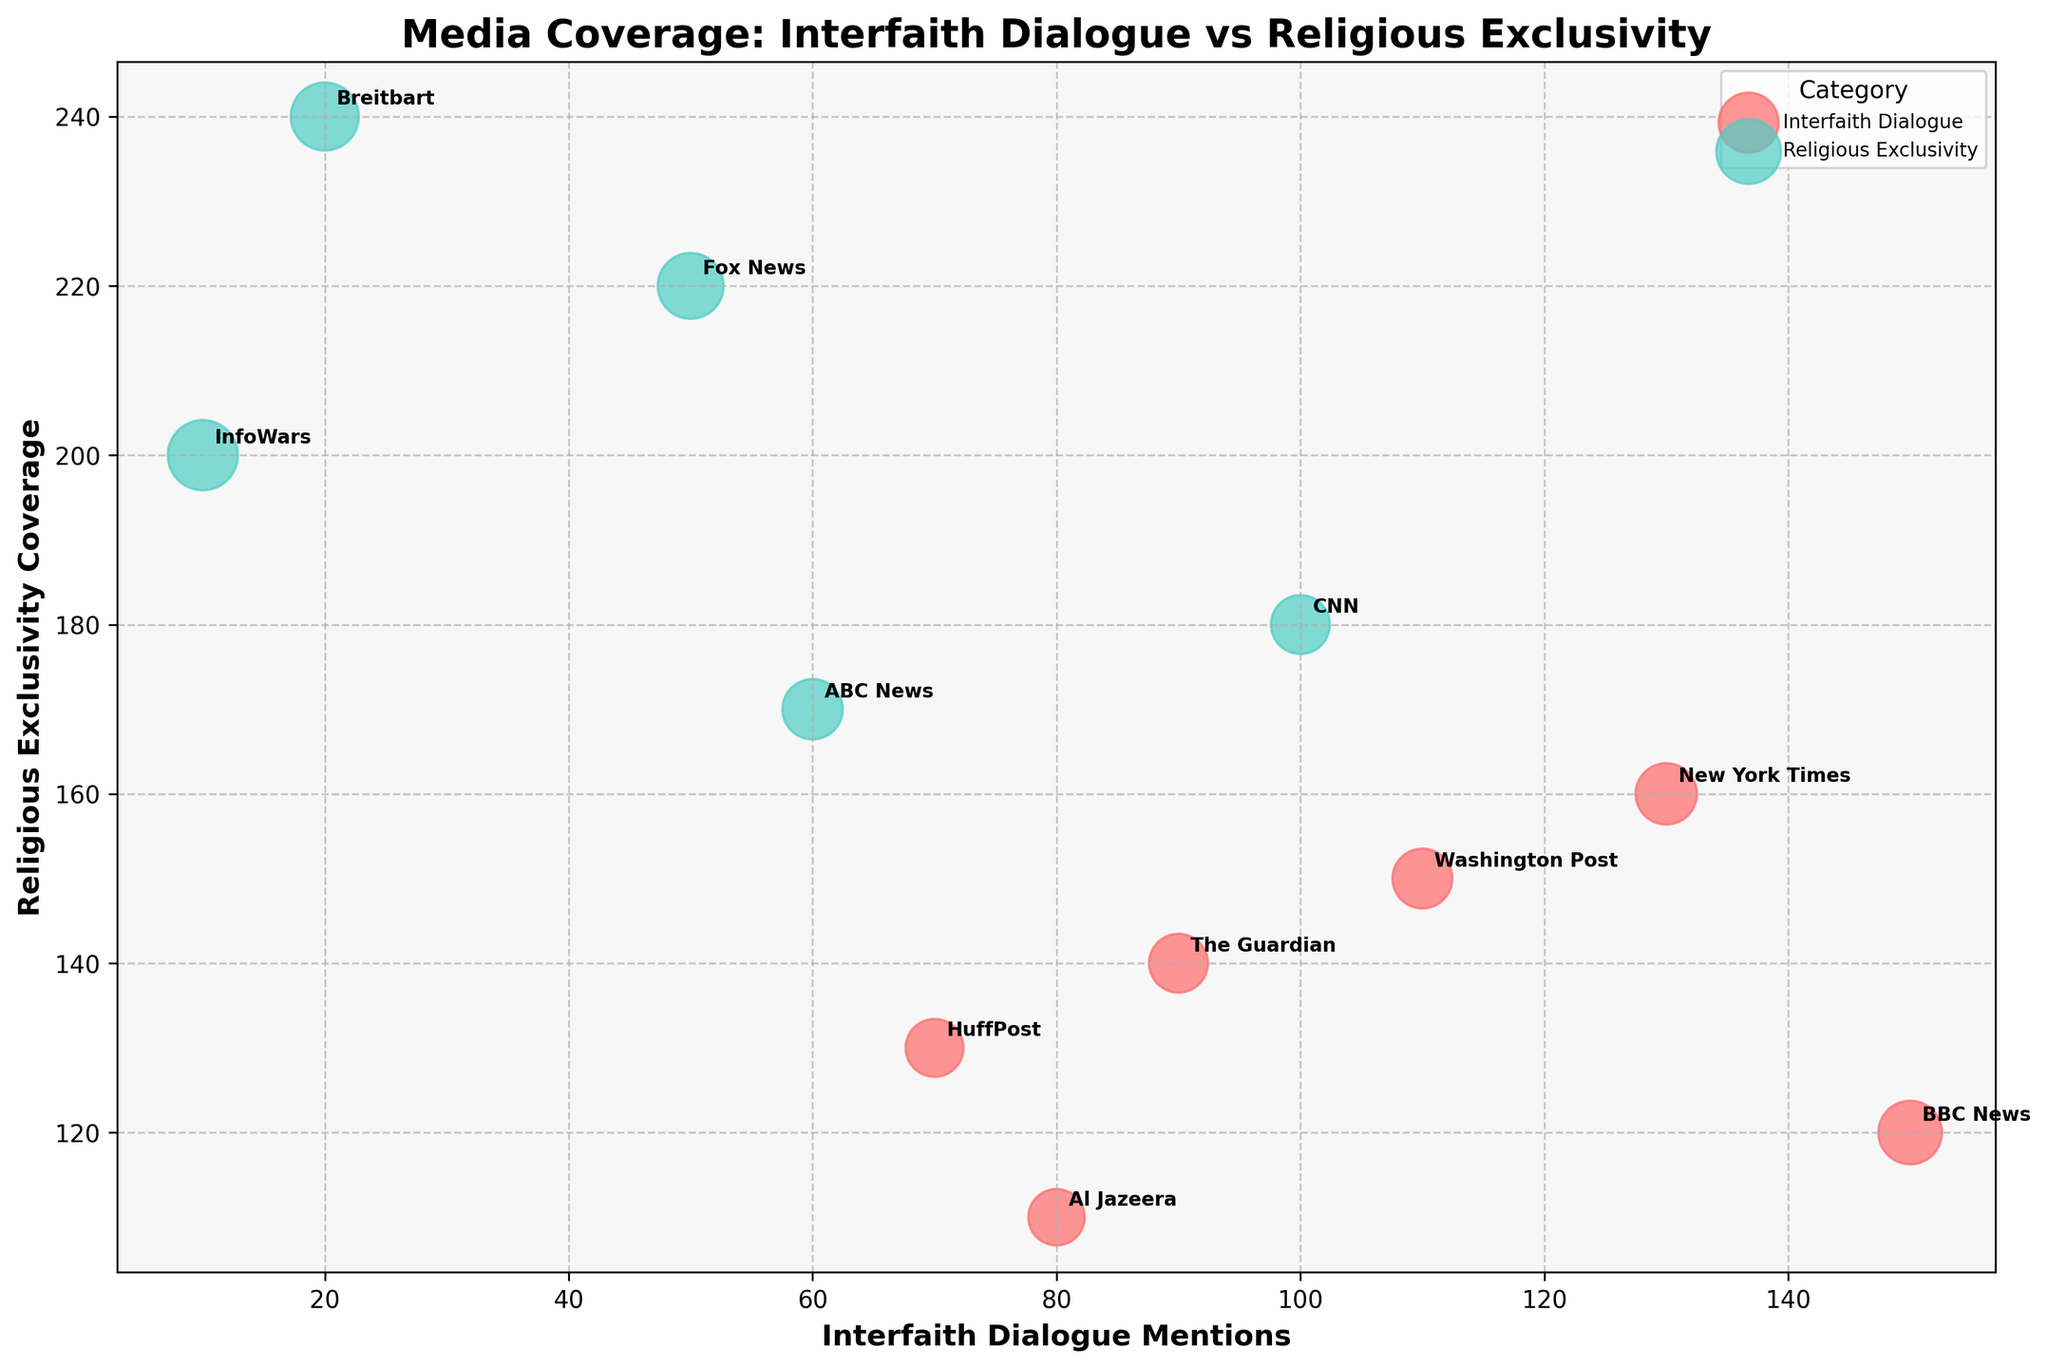What is the title of the chart? The title of the chart is typically found at the top and provides a summary of what the chart is about. Here, it reads: "Media Coverage: Interfaith Dialogue vs Religious Exclusivity".
Answer: "Media Coverage: Interfaith Dialogue vs Religious Exclusivity" How many media outlets are represented in the chart? Each unique label corresponds to a different media outlet. By counting the labels, we find that there are 11 media outlets represented in total.
Answer: 11 Which media outlet has the highest number of Religious Exclusivity Coverage mentions? By looking at the y-axis (Religious Exclusivity Coverage) and identifying the tallest bubble, InfoWars emerges as the outlet with the highest value (200 mentions).
Answer: InfoWars What is the Interfaith Dialogue Mentions for BBC News? By locating the BBC News label, we can see where it intersects with the x-axis, which indicates 150 Interfaith Dialogue Mentions.
Answer: 150 Which category appears more frequently in the chart, Interfaith Dialogue or Religious Exclusivity? By counting the number of data points (bubbles) of each color, we see there are more red bubbles (Interfaith Dialogue) compared to green bubbles (Religious Exclusivity).
Answer: Interfaith Dialogue How does Fox News compare to CNN in terms of Impact Score? Checking the size of the bubbles representing Fox News and CNN, we find that Fox News has a larger bubble, indicating a higher Impact Score (75 for Fox News versus 60 for CNN).
Answer: Fox News has a higher Impact Score than CNN Which media outlet has the smallest size bubble, and what does it represent? The smallest bubble in the chart represents InfoWars with an Impact Score of 85. This demonstrates that, even though it has fewer mentions, its impact is higher than others with smaller bubbles.
Answer: InfoWars What is the combined total of Religious Exclusivity Coverage mentions for Fox News and Breitbart? Add the y-axis values for Fox News (220) and Breitbart (240), which yields a total of 460 mentions.
Answer: 460 Which media outlet balances Interfaith Dialogue and Religious Exclusivity Coverage more equally? By looking at the bubbles closest to a diagonal line from the bottom left to the top right, BBC News appears balanced with 150 mentions for Interfaith Dialogue and 120 mentions for Religious Exclusivity Coverage.
Answer: BBC News Identify the media outlets that are categorized under Religious Exclusivity and list their Interfaith Dialogue Mentions. Media outlets labeled under Religious Exclusivity can be spotted by their green color. These outlets are CNN (100), Fox News (50), Breitbart (20), InfoWars (10), and ABC News (60).
Answer: CNN (100), Fox News (50), Breitbart (20), InfoWars (10), and ABC News (60) 